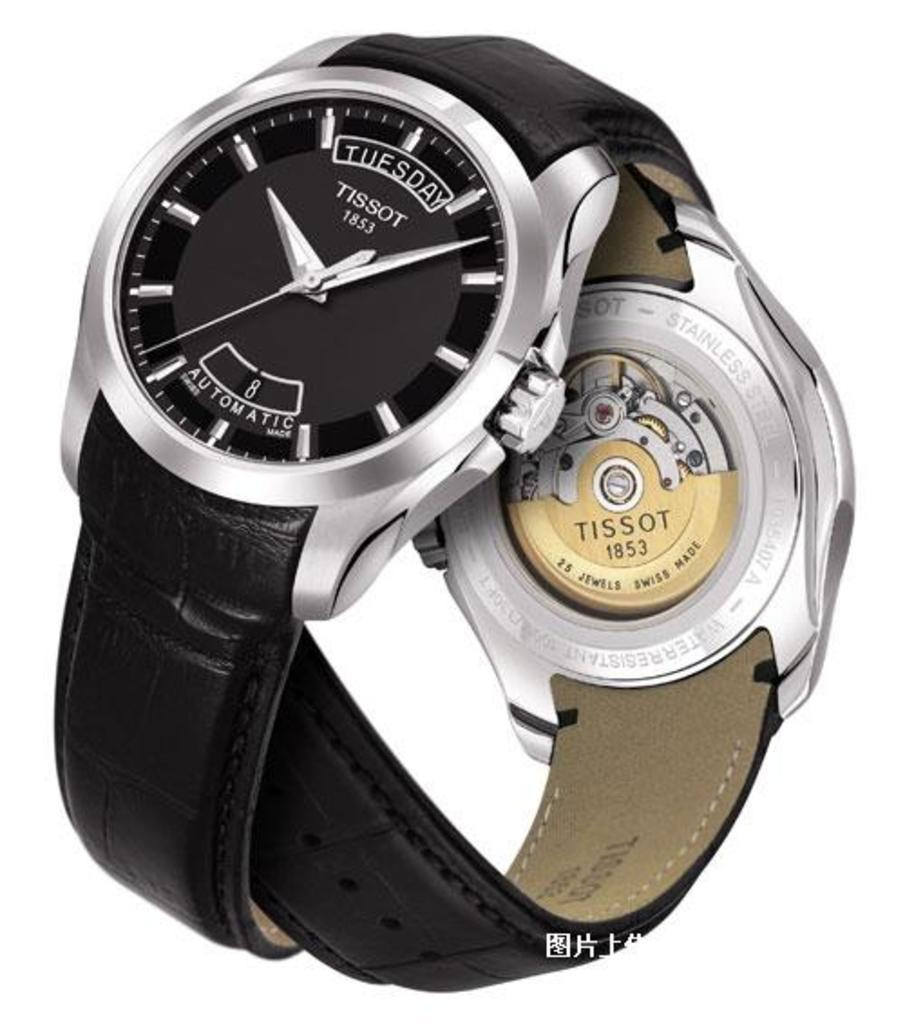<image>
Describe the image concisely. A black TISSOT brand watch determines that it is Tuesday. 